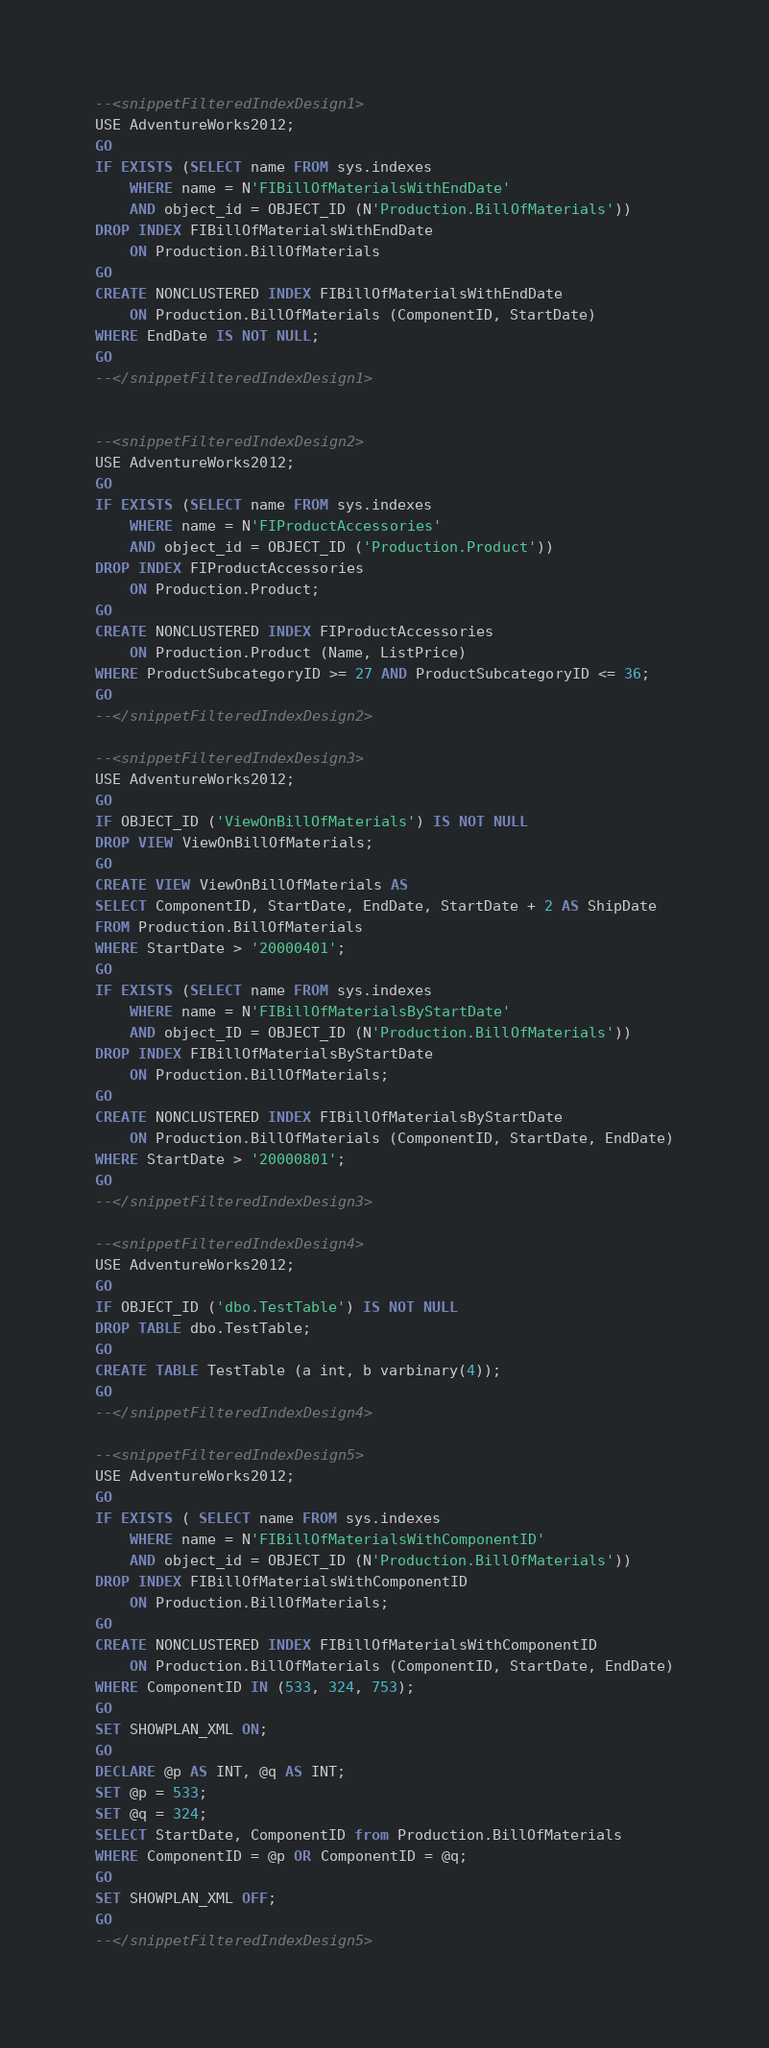Convert code to text. <code><loc_0><loc_0><loc_500><loc_500><_SQL_>--<snippetFilteredIndexDesign1>
USE AdventureWorks2012;
GO
IF EXISTS (SELECT name FROM sys.indexes
    WHERE name = N'FIBillOfMaterialsWithEndDate'
    AND object_id = OBJECT_ID (N'Production.BillOfMaterials'))
DROP INDEX FIBillOfMaterialsWithEndDate
    ON Production.BillOfMaterials
GO
CREATE NONCLUSTERED INDEX FIBillOfMaterialsWithEndDate
    ON Production.BillOfMaterials (ComponentID, StartDate)
WHERE EndDate IS NOT NULL;
GO
--</snippetFilteredIndexDesign1>


--<snippetFilteredIndexDesign2>
USE AdventureWorks2012;
GO
IF EXISTS (SELECT name FROM sys.indexes
    WHERE name = N'FIProductAccessories'
    AND object_id = OBJECT_ID ('Production.Product'))
DROP INDEX FIProductAccessories
    ON Production.Product;
GO
CREATE NONCLUSTERED INDEX FIProductAccessories
    ON Production.Product (Name, ListPrice)
WHERE ProductSubcategoryID >= 27 AND ProductSubcategoryID <= 36;
GO
--</snippetFilteredIndexDesign2>

--<snippetFilteredIndexDesign3>
USE AdventureWorks2012;
GO
IF OBJECT_ID ('ViewOnBillOfMaterials') IS NOT NULL
DROP VIEW ViewOnBillOfMaterials;
GO
CREATE VIEW ViewOnBillOfMaterials AS 
SELECT ComponentID, StartDate, EndDate, StartDate + 2 AS ShipDate
FROM Production.BillOfMaterials
WHERE StartDate > '20000401';
GO
IF EXISTS (SELECT name FROM sys.indexes
    WHERE name = N'FIBillOfMaterialsByStartDate'
    AND object_ID = OBJECT_ID (N'Production.BillOfMaterials'))
DROP INDEX FIBillOfMaterialsByStartDate 
    ON Production.BillOfMaterials;
GO
CREATE NONCLUSTERED INDEX FIBillOfMaterialsByStartDate
    ON Production.BillOfMaterials (ComponentID, StartDate, EndDate)
WHERE StartDate > '20000801';
GO
--</snippetFilteredIndexDesign3>

--<snippetFilteredIndexDesign4>
USE AdventureWorks2012;
GO
IF OBJECT_ID ('dbo.TestTable') IS NOT NULL
DROP TABLE dbo.TestTable;
GO
CREATE TABLE TestTable (a int, b varbinary(4));
GO
--</snippetFilteredIndexDesign4>

--<snippetFilteredIndexDesign5>
USE AdventureWorks2012;
GO
IF EXISTS ( SELECT name FROM sys.indexes
    WHERE name = N'FIBillOfMaterialsWithComponentID'
    AND object_id = OBJECT_ID (N'Production.BillOfMaterials'))
DROP INDEX FIBillOfMaterialsWithComponentID
    ON Production.BillOfMaterials;
GO
CREATE NONCLUSTERED INDEX FIBillOfMaterialsWithComponentID
    ON Production.BillOfMaterials (ComponentID, StartDate, EndDate)
WHERE ComponentID IN (533, 324, 753);
GO
SET SHOWPLAN_XML ON;
GO
DECLARE @p AS INT, @q AS INT;
SET @p = 533;
SET @q = 324;
SELECT StartDate, ComponentID from Production.BillOfMaterials 
WHERE ComponentID = @p OR ComponentID = @q;
GO
SET SHOWPLAN_XML OFF;
GO
--</snippetFilteredIndexDesign5>
</code> 